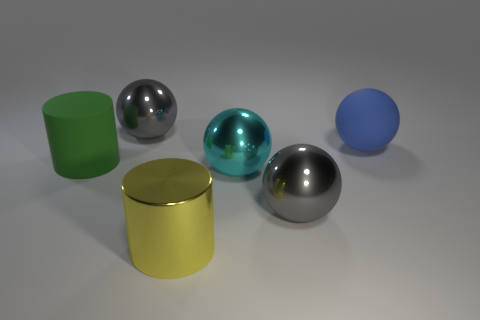How many gray spheres must be subtracted to get 1 gray spheres? 1 Subtract all spheres. How many objects are left? 2 Add 4 green rubber things. How many objects exist? 10 Add 1 balls. How many balls are left? 5 Add 3 big green metallic cubes. How many big green metallic cubes exist? 3 Subtract 1 yellow cylinders. How many objects are left? 5 Subtract all small gray metallic spheres. Subtract all yellow things. How many objects are left? 5 